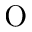Convert formula to latex. <formula><loc_0><loc_0><loc_500><loc_500>O</formula> 